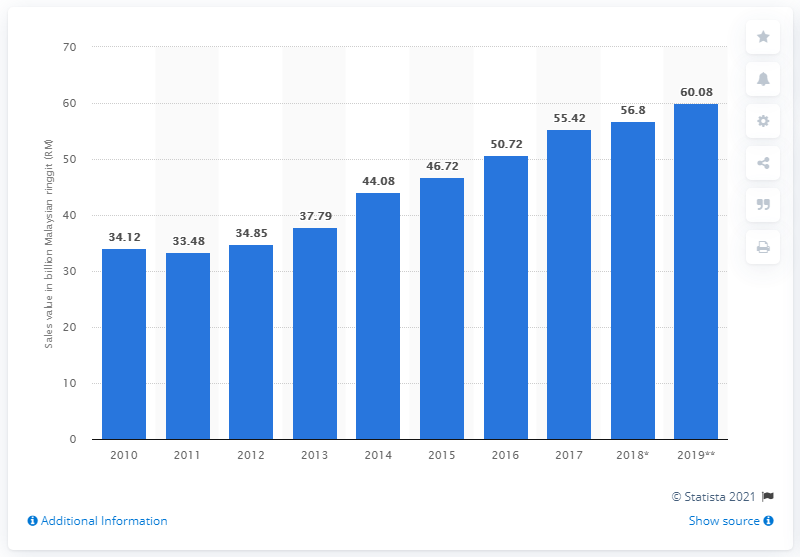Give some essential details in this illustration. In 2017, the electronic industry in Malaysia contributed a significant amount to the country's manufacturing value added, with a total of 55.42... 